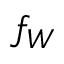Convert formula to latex. <formula><loc_0><loc_0><loc_500><loc_500>f _ { W }</formula> 